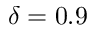Convert formula to latex. <formula><loc_0><loc_0><loc_500><loc_500>\delta = 0 . 9</formula> 